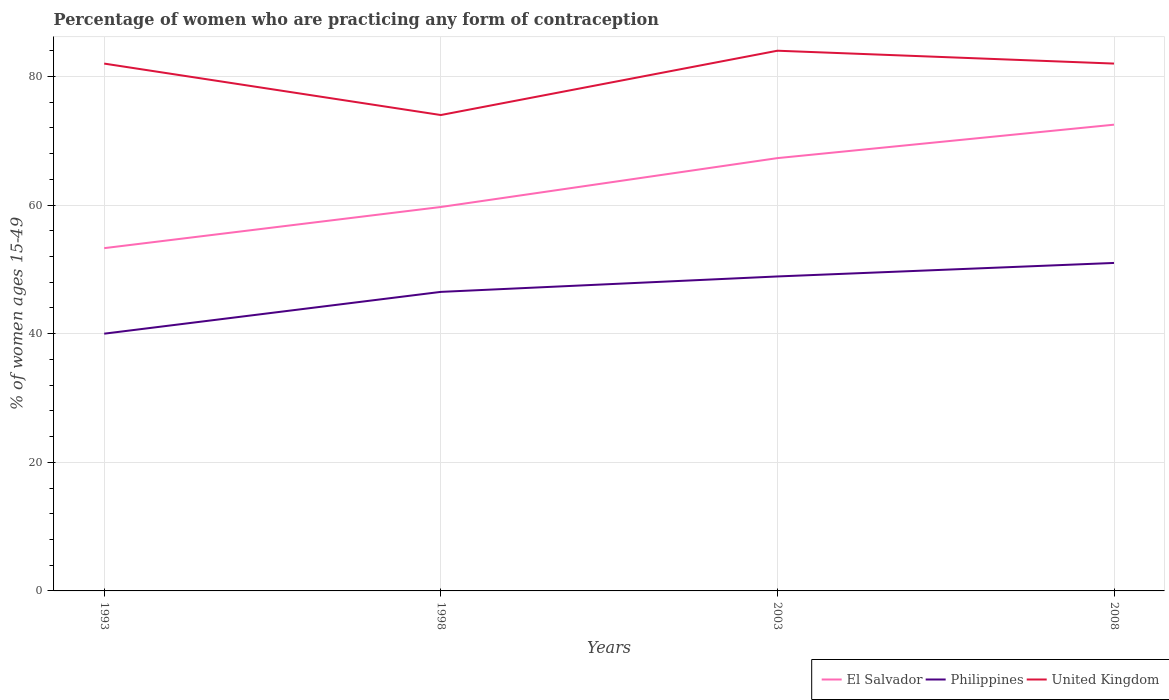Is the number of lines equal to the number of legend labels?
Keep it short and to the point. Yes. Across all years, what is the maximum percentage of women who are practicing any form of contraception in El Salvador?
Keep it short and to the point. 53.3. What is the total percentage of women who are practicing any form of contraception in El Salvador in the graph?
Make the answer very short. -5.2. What is the difference between the highest and the second highest percentage of women who are practicing any form of contraception in United Kingdom?
Keep it short and to the point. 10. What is the difference between the highest and the lowest percentage of women who are practicing any form of contraception in El Salvador?
Give a very brief answer. 2. How many years are there in the graph?
Offer a very short reply. 4. What is the difference between two consecutive major ticks on the Y-axis?
Provide a succinct answer. 20. Does the graph contain any zero values?
Provide a short and direct response. No. Where does the legend appear in the graph?
Offer a terse response. Bottom right. How many legend labels are there?
Offer a very short reply. 3. How are the legend labels stacked?
Give a very brief answer. Horizontal. What is the title of the graph?
Give a very brief answer. Percentage of women who are practicing any form of contraception. What is the label or title of the X-axis?
Make the answer very short. Years. What is the label or title of the Y-axis?
Provide a short and direct response. % of women ages 15-49. What is the % of women ages 15-49 in El Salvador in 1993?
Your answer should be compact. 53.3. What is the % of women ages 15-49 of Philippines in 1993?
Ensure brevity in your answer.  40. What is the % of women ages 15-49 of El Salvador in 1998?
Give a very brief answer. 59.7. What is the % of women ages 15-49 of Philippines in 1998?
Keep it short and to the point. 46.5. What is the % of women ages 15-49 in El Salvador in 2003?
Provide a succinct answer. 67.3. What is the % of women ages 15-49 in Philippines in 2003?
Keep it short and to the point. 48.9. What is the % of women ages 15-49 in United Kingdom in 2003?
Provide a succinct answer. 84. What is the % of women ages 15-49 in El Salvador in 2008?
Keep it short and to the point. 72.5. What is the % of women ages 15-49 in United Kingdom in 2008?
Your answer should be very brief. 82. Across all years, what is the maximum % of women ages 15-49 of El Salvador?
Make the answer very short. 72.5. Across all years, what is the maximum % of women ages 15-49 of Philippines?
Give a very brief answer. 51. Across all years, what is the maximum % of women ages 15-49 in United Kingdom?
Keep it short and to the point. 84. Across all years, what is the minimum % of women ages 15-49 in El Salvador?
Make the answer very short. 53.3. Across all years, what is the minimum % of women ages 15-49 of United Kingdom?
Provide a succinct answer. 74. What is the total % of women ages 15-49 in El Salvador in the graph?
Your response must be concise. 252.8. What is the total % of women ages 15-49 in Philippines in the graph?
Offer a very short reply. 186.4. What is the total % of women ages 15-49 in United Kingdom in the graph?
Offer a terse response. 322. What is the difference between the % of women ages 15-49 in Philippines in 1993 and that in 1998?
Your answer should be very brief. -6.5. What is the difference between the % of women ages 15-49 in United Kingdom in 1993 and that in 1998?
Make the answer very short. 8. What is the difference between the % of women ages 15-49 of Philippines in 1993 and that in 2003?
Offer a very short reply. -8.9. What is the difference between the % of women ages 15-49 of United Kingdom in 1993 and that in 2003?
Ensure brevity in your answer.  -2. What is the difference between the % of women ages 15-49 in El Salvador in 1993 and that in 2008?
Your answer should be compact. -19.2. What is the difference between the % of women ages 15-49 in United Kingdom in 1993 and that in 2008?
Keep it short and to the point. 0. What is the difference between the % of women ages 15-49 of Philippines in 1998 and that in 2008?
Give a very brief answer. -4.5. What is the difference between the % of women ages 15-49 of El Salvador in 2003 and that in 2008?
Ensure brevity in your answer.  -5.2. What is the difference between the % of women ages 15-49 of Philippines in 2003 and that in 2008?
Provide a short and direct response. -2.1. What is the difference between the % of women ages 15-49 in El Salvador in 1993 and the % of women ages 15-49 in United Kingdom in 1998?
Make the answer very short. -20.7. What is the difference between the % of women ages 15-49 in Philippines in 1993 and the % of women ages 15-49 in United Kingdom in 1998?
Offer a terse response. -34. What is the difference between the % of women ages 15-49 in El Salvador in 1993 and the % of women ages 15-49 in United Kingdom in 2003?
Make the answer very short. -30.7. What is the difference between the % of women ages 15-49 of Philippines in 1993 and the % of women ages 15-49 of United Kingdom in 2003?
Provide a succinct answer. -44. What is the difference between the % of women ages 15-49 in El Salvador in 1993 and the % of women ages 15-49 in Philippines in 2008?
Give a very brief answer. 2.3. What is the difference between the % of women ages 15-49 of El Salvador in 1993 and the % of women ages 15-49 of United Kingdom in 2008?
Ensure brevity in your answer.  -28.7. What is the difference between the % of women ages 15-49 of Philippines in 1993 and the % of women ages 15-49 of United Kingdom in 2008?
Provide a short and direct response. -42. What is the difference between the % of women ages 15-49 of El Salvador in 1998 and the % of women ages 15-49 of United Kingdom in 2003?
Your answer should be very brief. -24.3. What is the difference between the % of women ages 15-49 in Philippines in 1998 and the % of women ages 15-49 in United Kingdom in 2003?
Offer a very short reply. -37.5. What is the difference between the % of women ages 15-49 of El Salvador in 1998 and the % of women ages 15-49 of United Kingdom in 2008?
Offer a very short reply. -22.3. What is the difference between the % of women ages 15-49 in Philippines in 1998 and the % of women ages 15-49 in United Kingdom in 2008?
Make the answer very short. -35.5. What is the difference between the % of women ages 15-49 of El Salvador in 2003 and the % of women ages 15-49 of Philippines in 2008?
Ensure brevity in your answer.  16.3. What is the difference between the % of women ages 15-49 of El Salvador in 2003 and the % of women ages 15-49 of United Kingdom in 2008?
Your answer should be compact. -14.7. What is the difference between the % of women ages 15-49 in Philippines in 2003 and the % of women ages 15-49 in United Kingdom in 2008?
Offer a terse response. -33.1. What is the average % of women ages 15-49 of El Salvador per year?
Your answer should be very brief. 63.2. What is the average % of women ages 15-49 of Philippines per year?
Provide a short and direct response. 46.6. What is the average % of women ages 15-49 of United Kingdom per year?
Offer a terse response. 80.5. In the year 1993, what is the difference between the % of women ages 15-49 of El Salvador and % of women ages 15-49 of Philippines?
Provide a succinct answer. 13.3. In the year 1993, what is the difference between the % of women ages 15-49 of El Salvador and % of women ages 15-49 of United Kingdom?
Keep it short and to the point. -28.7. In the year 1993, what is the difference between the % of women ages 15-49 in Philippines and % of women ages 15-49 in United Kingdom?
Keep it short and to the point. -42. In the year 1998, what is the difference between the % of women ages 15-49 of El Salvador and % of women ages 15-49 of United Kingdom?
Provide a short and direct response. -14.3. In the year 1998, what is the difference between the % of women ages 15-49 in Philippines and % of women ages 15-49 in United Kingdom?
Provide a succinct answer. -27.5. In the year 2003, what is the difference between the % of women ages 15-49 in El Salvador and % of women ages 15-49 in United Kingdom?
Ensure brevity in your answer.  -16.7. In the year 2003, what is the difference between the % of women ages 15-49 of Philippines and % of women ages 15-49 of United Kingdom?
Offer a terse response. -35.1. In the year 2008, what is the difference between the % of women ages 15-49 of El Salvador and % of women ages 15-49 of Philippines?
Ensure brevity in your answer.  21.5. In the year 2008, what is the difference between the % of women ages 15-49 in El Salvador and % of women ages 15-49 in United Kingdom?
Offer a very short reply. -9.5. In the year 2008, what is the difference between the % of women ages 15-49 in Philippines and % of women ages 15-49 in United Kingdom?
Your response must be concise. -31. What is the ratio of the % of women ages 15-49 in El Salvador in 1993 to that in 1998?
Keep it short and to the point. 0.89. What is the ratio of the % of women ages 15-49 in Philippines in 1993 to that in 1998?
Offer a very short reply. 0.86. What is the ratio of the % of women ages 15-49 of United Kingdom in 1993 to that in 1998?
Keep it short and to the point. 1.11. What is the ratio of the % of women ages 15-49 of El Salvador in 1993 to that in 2003?
Give a very brief answer. 0.79. What is the ratio of the % of women ages 15-49 of Philippines in 1993 to that in 2003?
Your answer should be compact. 0.82. What is the ratio of the % of women ages 15-49 of United Kingdom in 1993 to that in 2003?
Your answer should be very brief. 0.98. What is the ratio of the % of women ages 15-49 of El Salvador in 1993 to that in 2008?
Provide a short and direct response. 0.74. What is the ratio of the % of women ages 15-49 of Philippines in 1993 to that in 2008?
Ensure brevity in your answer.  0.78. What is the ratio of the % of women ages 15-49 of United Kingdom in 1993 to that in 2008?
Give a very brief answer. 1. What is the ratio of the % of women ages 15-49 in El Salvador in 1998 to that in 2003?
Your response must be concise. 0.89. What is the ratio of the % of women ages 15-49 of Philippines in 1998 to that in 2003?
Keep it short and to the point. 0.95. What is the ratio of the % of women ages 15-49 in United Kingdom in 1998 to that in 2003?
Offer a very short reply. 0.88. What is the ratio of the % of women ages 15-49 of El Salvador in 1998 to that in 2008?
Offer a very short reply. 0.82. What is the ratio of the % of women ages 15-49 in Philippines in 1998 to that in 2008?
Make the answer very short. 0.91. What is the ratio of the % of women ages 15-49 of United Kingdom in 1998 to that in 2008?
Your response must be concise. 0.9. What is the ratio of the % of women ages 15-49 in El Salvador in 2003 to that in 2008?
Offer a very short reply. 0.93. What is the ratio of the % of women ages 15-49 of Philippines in 2003 to that in 2008?
Your answer should be compact. 0.96. What is the ratio of the % of women ages 15-49 of United Kingdom in 2003 to that in 2008?
Keep it short and to the point. 1.02. What is the difference between the highest and the second highest % of women ages 15-49 in El Salvador?
Give a very brief answer. 5.2. What is the difference between the highest and the lowest % of women ages 15-49 in United Kingdom?
Your answer should be very brief. 10. 